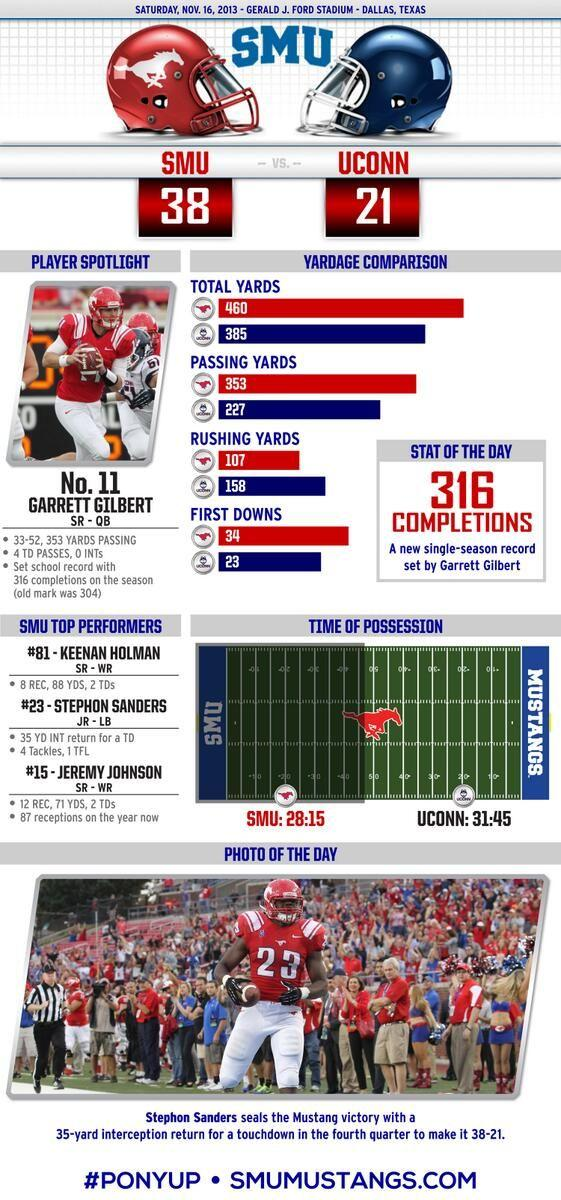Specify some key components in this picture. It is clear that Stephon Sanders is the player who is depicted at the bottom. I declare that the animal depicted on the red helmet is a horse, not an elephant or rabbit. 